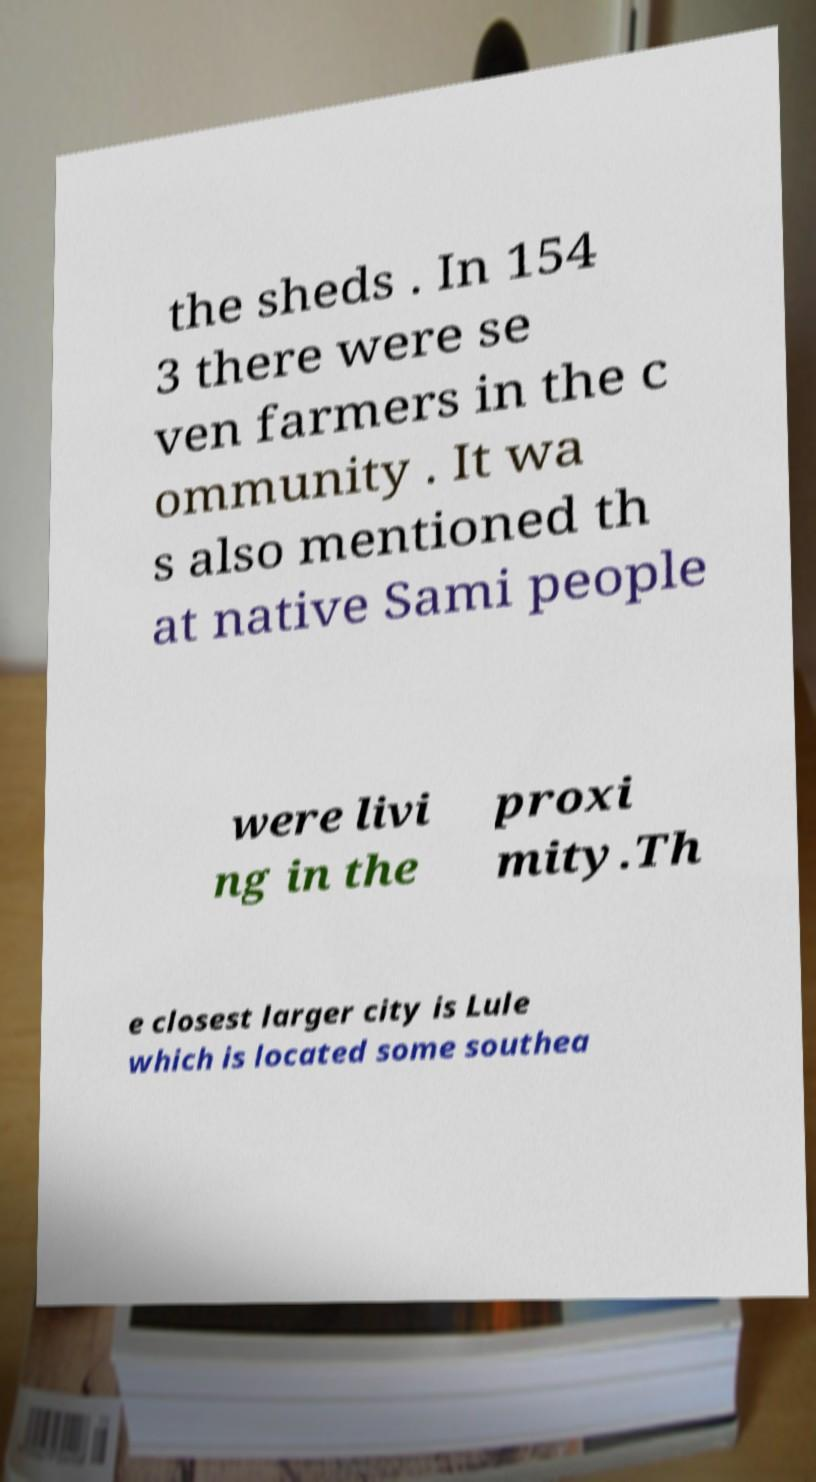Please identify and transcribe the text found in this image. the sheds . In 154 3 there were se ven farmers in the c ommunity . It wa s also mentioned th at native Sami people were livi ng in the proxi mity.Th e closest larger city is Lule which is located some southea 